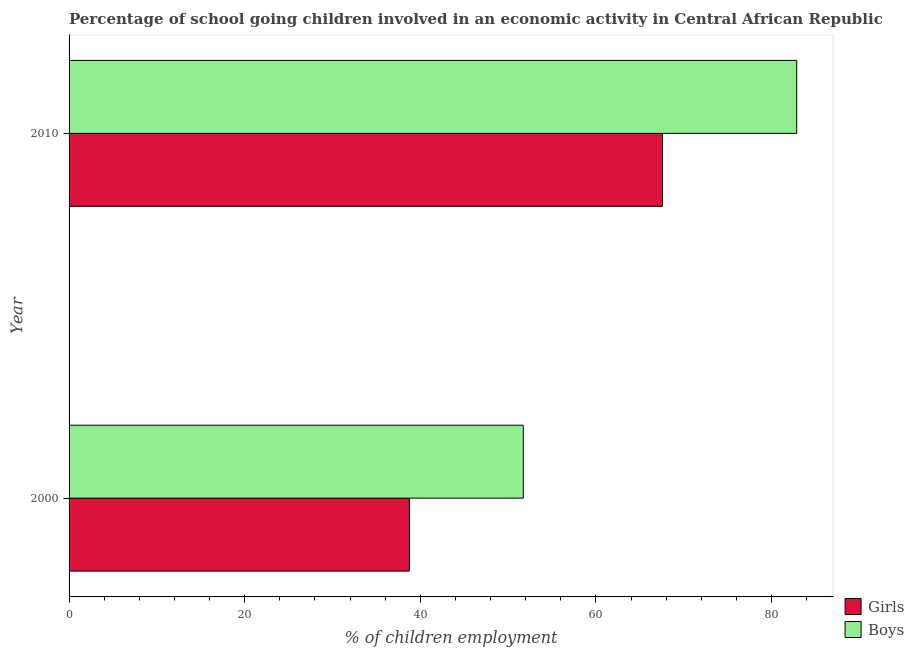How many different coloured bars are there?
Ensure brevity in your answer.  2. How many groups of bars are there?
Keep it short and to the point. 2. Are the number of bars per tick equal to the number of legend labels?
Give a very brief answer. Yes. How many bars are there on the 2nd tick from the top?
Your answer should be very brief. 2. What is the label of the 2nd group of bars from the top?
Offer a very short reply. 2000. What is the percentage of school going boys in 2000?
Your response must be concise. 51.73. Across all years, what is the maximum percentage of school going girls?
Ensure brevity in your answer.  67.58. Across all years, what is the minimum percentage of school going girls?
Keep it short and to the point. 38.76. In which year was the percentage of school going girls maximum?
Provide a short and direct response. 2010. What is the total percentage of school going girls in the graph?
Offer a terse response. 106.34. What is the difference between the percentage of school going girls in 2000 and that in 2010?
Keep it short and to the point. -28.82. What is the difference between the percentage of school going girls in 2000 and the percentage of school going boys in 2010?
Your answer should be very brief. -44.11. What is the average percentage of school going boys per year?
Keep it short and to the point. 67.3. In the year 2010, what is the difference between the percentage of school going boys and percentage of school going girls?
Your answer should be very brief. 15.29. What is the ratio of the percentage of school going girls in 2000 to that in 2010?
Your response must be concise. 0.57. Is the percentage of school going girls in 2000 less than that in 2010?
Ensure brevity in your answer.  Yes. What does the 2nd bar from the top in 2000 represents?
Make the answer very short. Girls. What does the 1st bar from the bottom in 2010 represents?
Give a very brief answer. Girls. How many bars are there?
Provide a short and direct response. 4. Are the values on the major ticks of X-axis written in scientific E-notation?
Your answer should be compact. No. Does the graph contain any zero values?
Your answer should be compact. No. Does the graph contain grids?
Keep it short and to the point. No. How many legend labels are there?
Ensure brevity in your answer.  2. What is the title of the graph?
Your answer should be compact. Percentage of school going children involved in an economic activity in Central African Republic. Does "Long-term debt" appear as one of the legend labels in the graph?
Give a very brief answer. No. What is the label or title of the X-axis?
Offer a very short reply. % of children employment. What is the % of children employment of Girls in 2000?
Keep it short and to the point. 38.76. What is the % of children employment of Boys in 2000?
Make the answer very short. 51.73. What is the % of children employment in Girls in 2010?
Your answer should be very brief. 67.58. What is the % of children employment of Boys in 2010?
Ensure brevity in your answer.  82.87. Across all years, what is the maximum % of children employment of Girls?
Provide a short and direct response. 67.58. Across all years, what is the maximum % of children employment in Boys?
Your answer should be very brief. 82.87. Across all years, what is the minimum % of children employment in Girls?
Your answer should be compact. 38.76. Across all years, what is the minimum % of children employment in Boys?
Offer a terse response. 51.73. What is the total % of children employment in Girls in the graph?
Make the answer very short. 106.34. What is the total % of children employment in Boys in the graph?
Give a very brief answer. 134.6. What is the difference between the % of children employment of Girls in 2000 and that in 2010?
Provide a short and direct response. -28.82. What is the difference between the % of children employment in Boys in 2000 and that in 2010?
Offer a terse response. -31.14. What is the difference between the % of children employment in Girls in 2000 and the % of children employment in Boys in 2010?
Keep it short and to the point. -44.11. What is the average % of children employment in Girls per year?
Offer a terse response. 53.17. What is the average % of children employment in Boys per year?
Offer a very short reply. 67.3. In the year 2000, what is the difference between the % of children employment in Girls and % of children employment in Boys?
Offer a very short reply. -12.97. In the year 2010, what is the difference between the % of children employment in Girls and % of children employment in Boys?
Your response must be concise. -15.29. What is the ratio of the % of children employment in Girls in 2000 to that in 2010?
Ensure brevity in your answer.  0.57. What is the ratio of the % of children employment of Boys in 2000 to that in 2010?
Provide a short and direct response. 0.62. What is the difference between the highest and the second highest % of children employment in Girls?
Give a very brief answer. 28.82. What is the difference between the highest and the second highest % of children employment of Boys?
Offer a terse response. 31.14. What is the difference between the highest and the lowest % of children employment in Girls?
Keep it short and to the point. 28.82. What is the difference between the highest and the lowest % of children employment in Boys?
Provide a succinct answer. 31.14. 